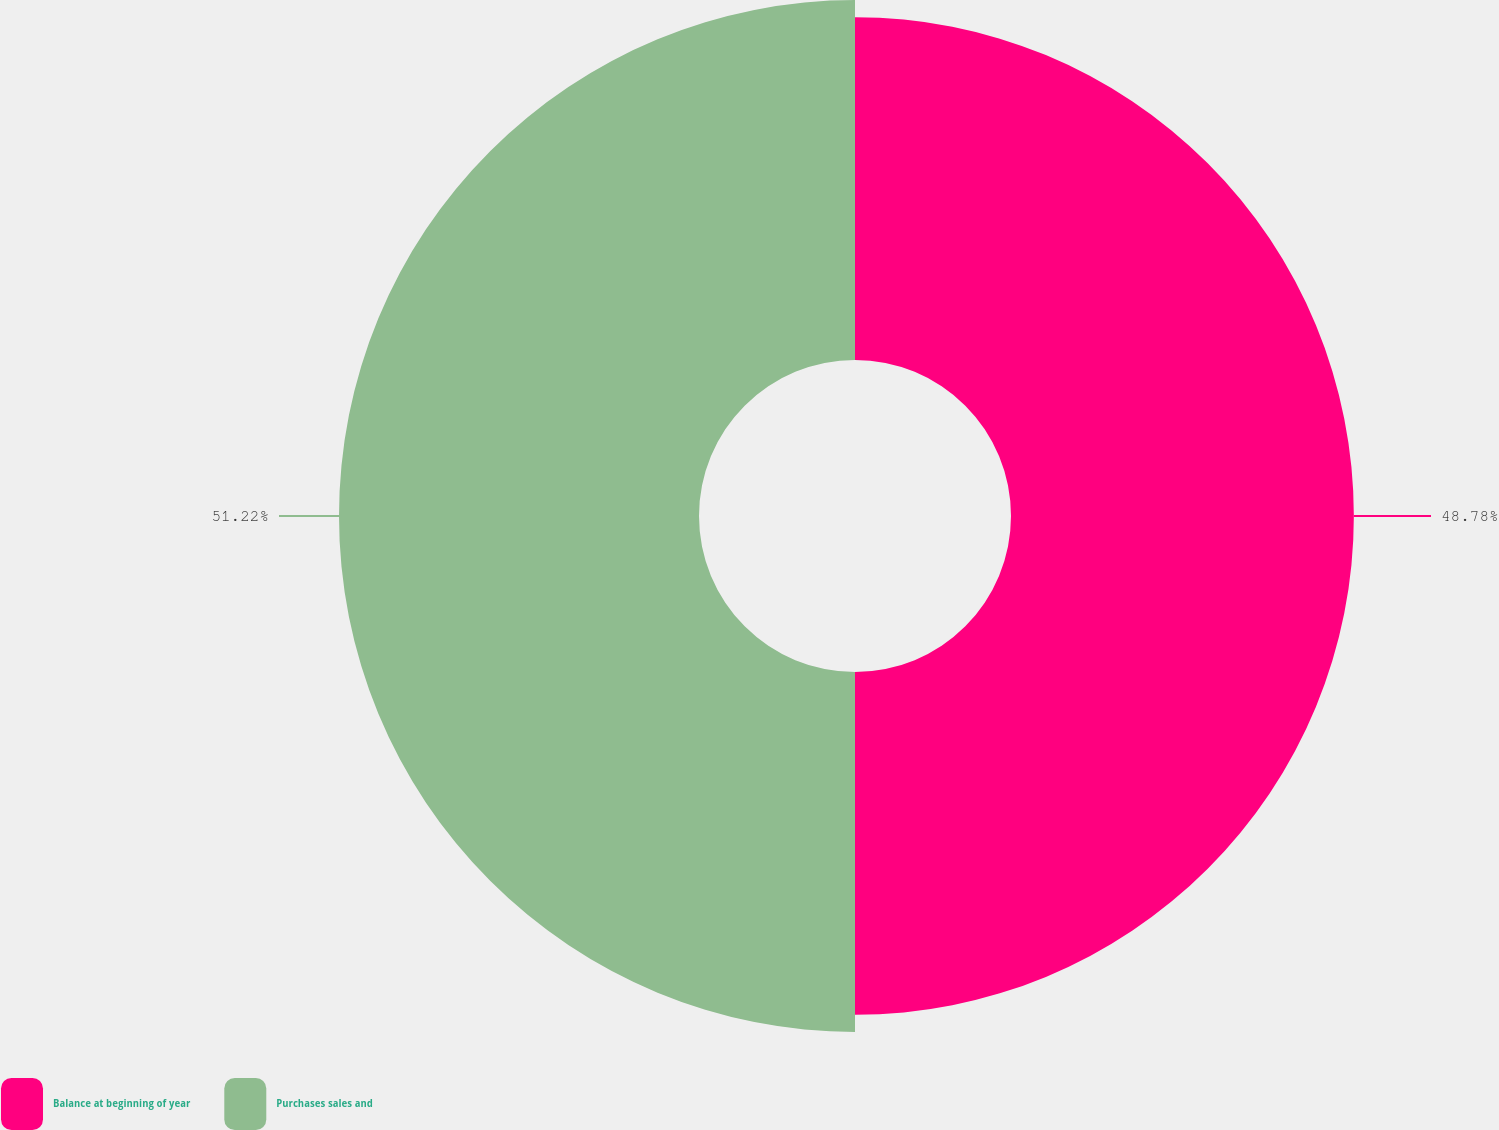Convert chart. <chart><loc_0><loc_0><loc_500><loc_500><pie_chart><fcel>Balance at beginning of year<fcel>Purchases sales and<nl><fcel>48.78%<fcel>51.22%<nl></chart> 